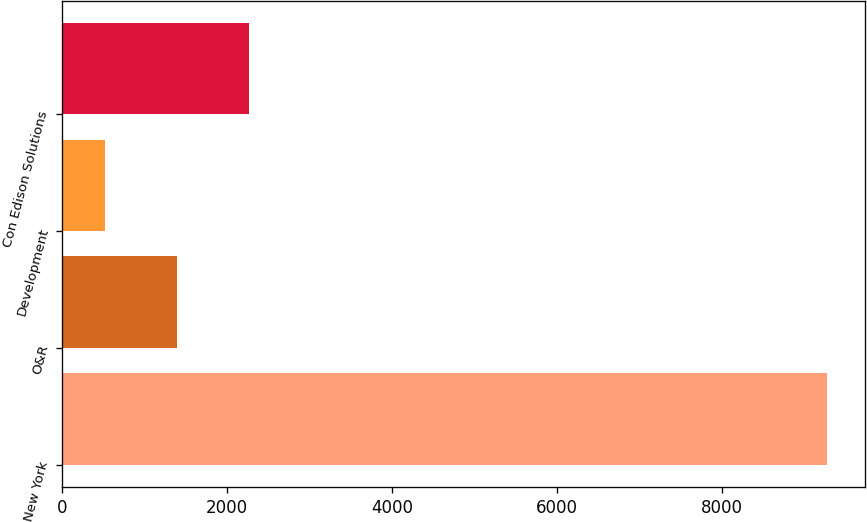Convert chart. <chart><loc_0><loc_0><loc_500><loc_500><bar_chart><fcel>New York<fcel>O&R<fcel>Development<fcel>Con Edison Solutions<nl><fcel>9272<fcel>1388<fcel>512<fcel>2264<nl></chart> 